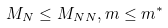<formula> <loc_0><loc_0><loc_500><loc_500>M _ { N } \leq M _ { N N } , m \leq m ^ { \ast }</formula> 